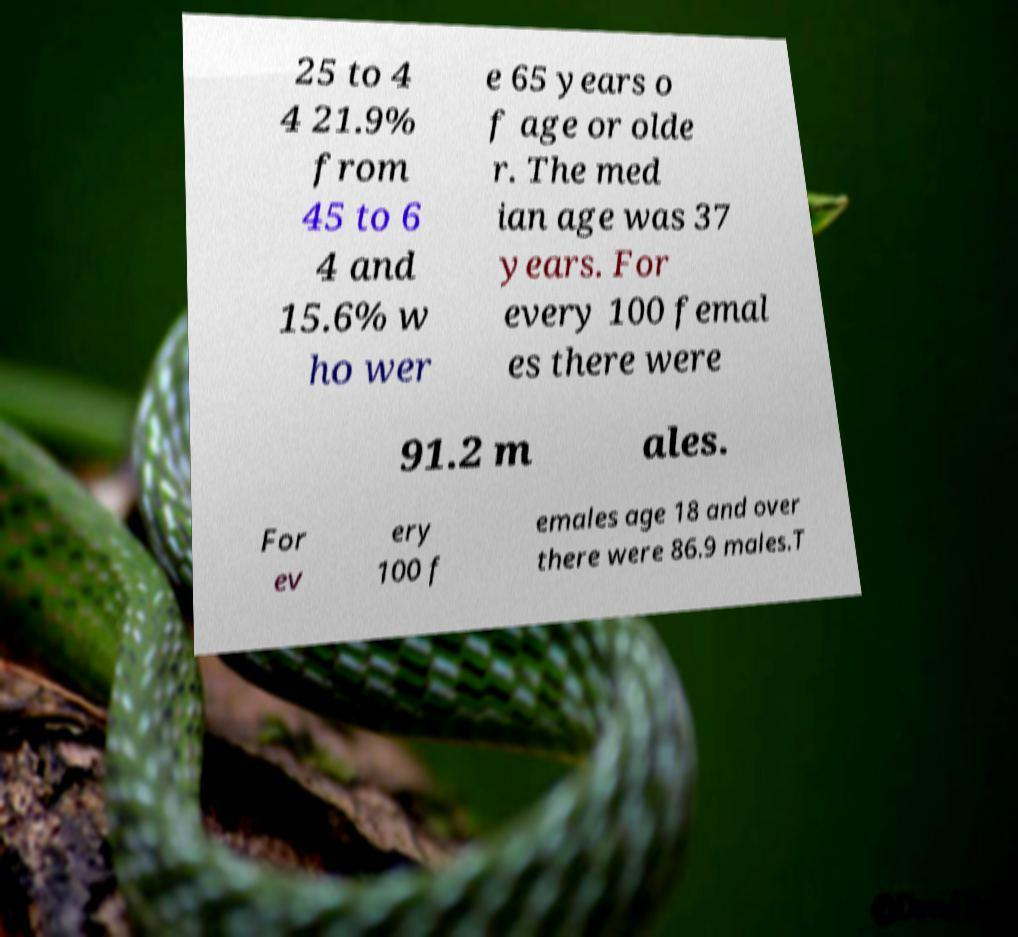Can you accurately transcribe the text from the provided image for me? 25 to 4 4 21.9% from 45 to 6 4 and 15.6% w ho wer e 65 years o f age or olde r. The med ian age was 37 years. For every 100 femal es there were 91.2 m ales. For ev ery 100 f emales age 18 and over there were 86.9 males.T 